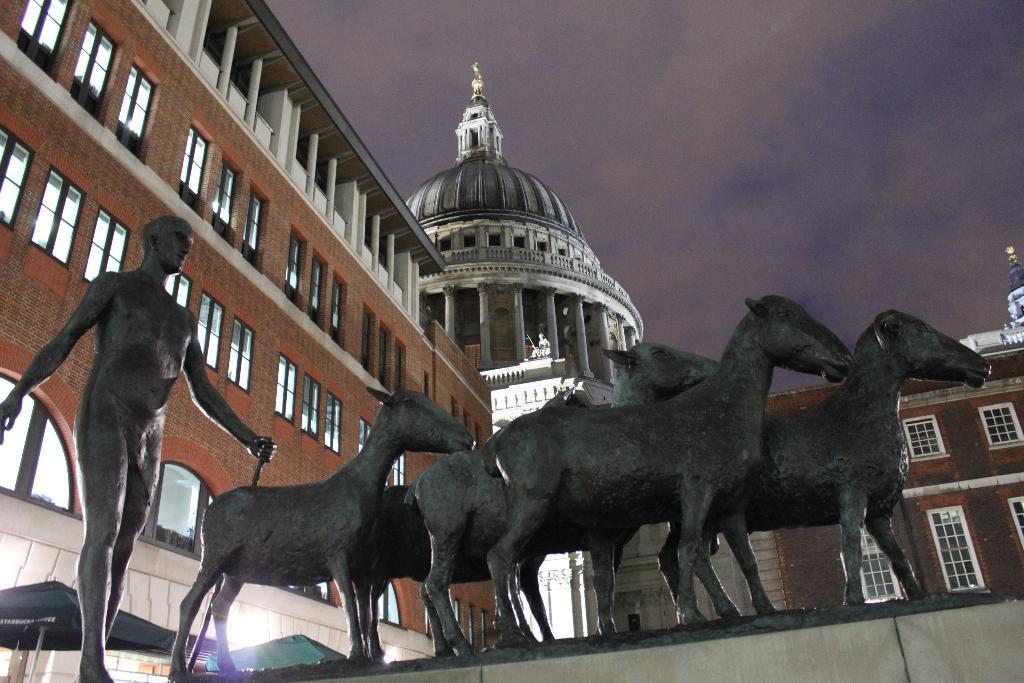What is the main subject in the foreground of the image? There is a statue in the foreground of the image. What can be seen in the background of the image? There are buildings in the background of the image. Can you describe any specific features of the buildings? Yes, there is a dome at the top of one of the buildings. What is the condition of the sky in the image? The sky is clear and visible in the image. How many friends are sitting on the statue in the image? There are no friends sitting on the statue in the image; it is a statue and not a place for people to sit. Can you see any frogs on the statue or near it in the image? There are no frogs present in the image. 